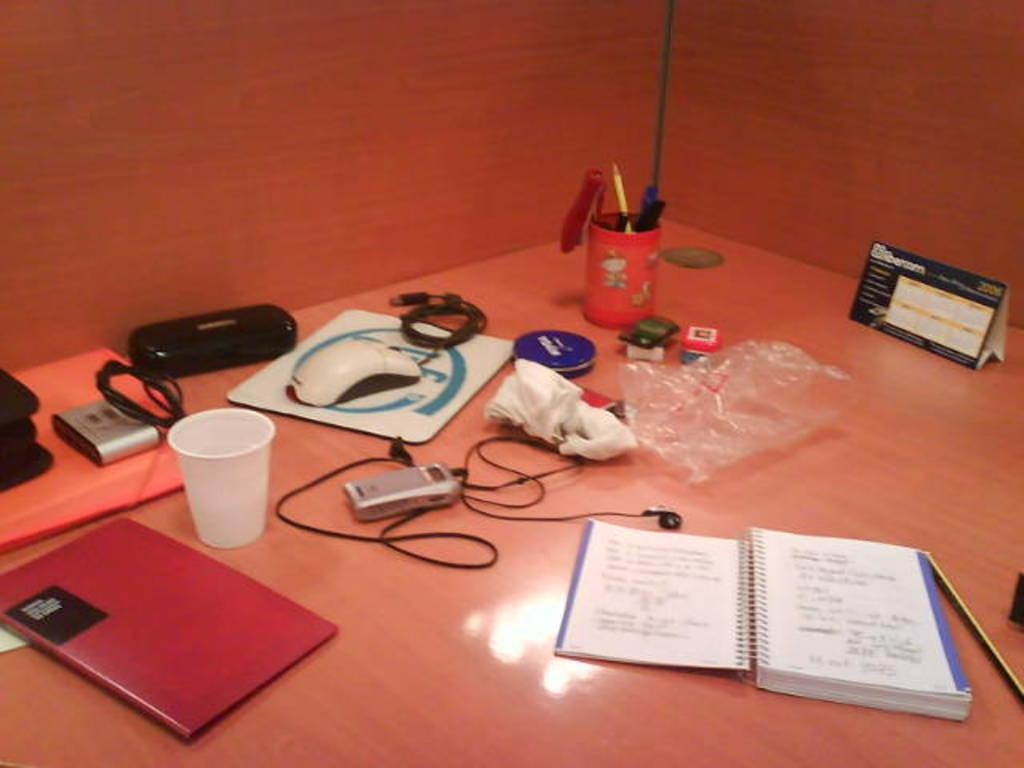What piece of furniture is present in the image? There is a table in the image. What electronic device is on the table? There is a camera on the table. What other objects can be seen on the table? There is a box, a glass, a book, a wired object, a mouse, and a poster on the table. What type of acoustics can be heard from the poster in the image? There is no information about the acoustics of the poster in the image, as it only mentions the presence of a poster. How many tickets are visible in the image? There is no mention of tickets in the image, so it is impossible to determine the number of tickets present. 